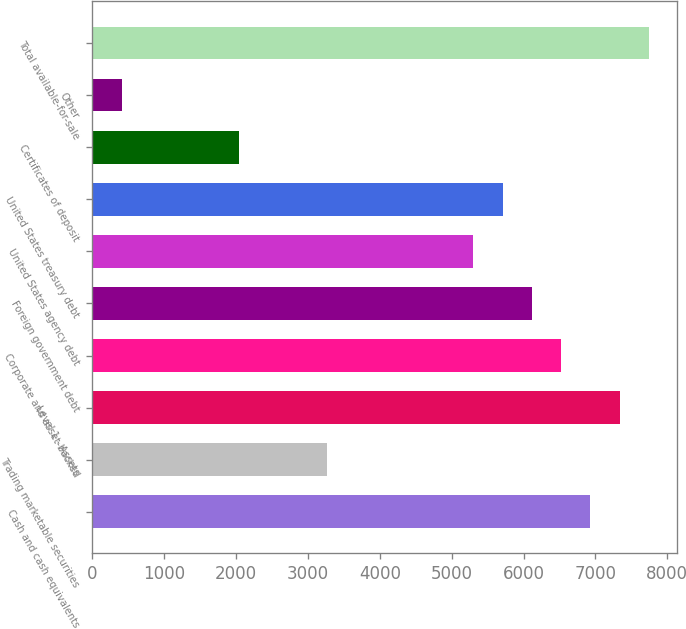Convert chart to OTSL. <chart><loc_0><loc_0><loc_500><loc_500><bar_chart><fcel>Cash and cash equivalents<fcel>Trading marketable securities<fcel>Level 1 - Assets<fcel>Corporate and asset-backed<fcel>Foreign government debt<fcel>United States agency debt<fcel>United States treasury debt<fcel>Certificates of deposit<fcel>Other<fcel>Total available-for-sale<nl><fcel>6929.5<fcel>3262<fcel>7337<fcel>6522<fcel>6114.5<fcel>5299.5<fcel>5707<fcel>2039.5<fcel>409.5<fcel>7744.5<nl></chart> 